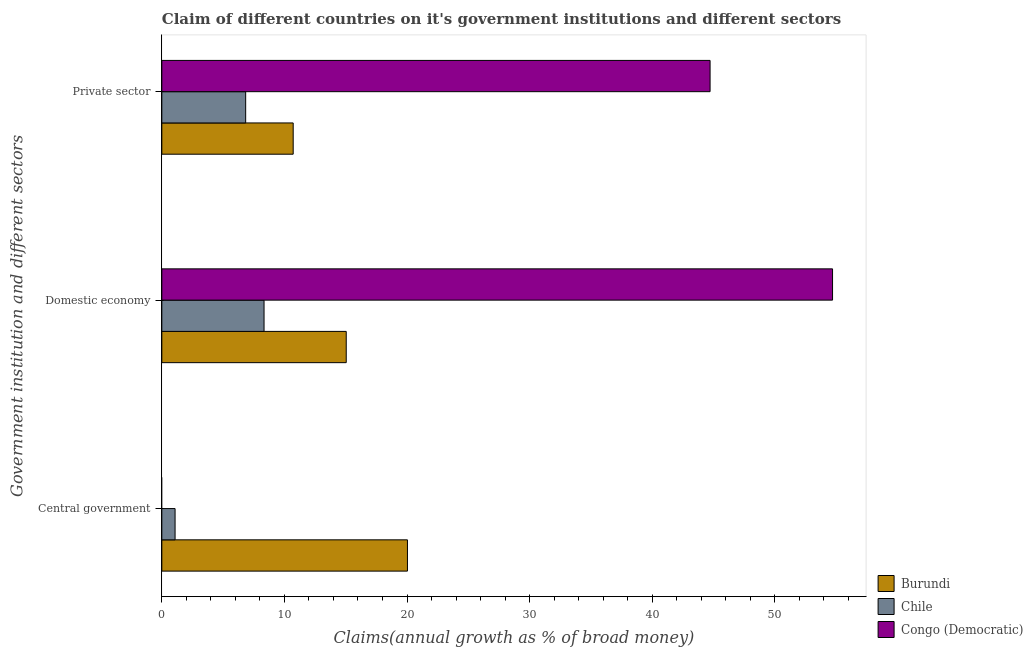How many different coloured bars are there?
Offer a very short reply. 3. How many groups of bars are there?
Provide a succinct answer. 3. Are the number of bars per tick equal to the number of legend labels?
Give a very brief answer. No. How many bars are there on the 1st tick from the top?
Your response must be concise. 3. How many bars are there on the 2nd tick from the bottom?
Make the answer very short. 3. What is the label of the 1st group of bars from the top?
Offer a very short reply. Private sector. What is the percentage of claim on the private sector in Congo (Democratic)?
Give a very brief answer. 44.72. Across all countries, what is the maximum percentage of claim on the domestic economy?
Offer a terse response. 54.71. Across all countries, what is the minimum percentage of claim on the private sector?
Your answer should be very brief. 6.84. In which country was the percentage of claim on the central government maximum?
Provide a short and direct response. Burundi. What is the total percentage of claim on the private sector in the graph?
Give a very brief answer. 62.28. What is the difference between the percentage of claim on the domestic economy in Chile and that in Burundi?
Provide a succinct answer. -6.7. What is the difference between the percentage of claim on the private sector in Congo (Democratic) and the percentage of claim on the domestic economy in Burundi?
Offer a very short reply. 29.68. What is the average percentage of claim on the domestic economy per country?
Ensure brevity in your answer.  26.03. What is the difference between the percentage of claim on the private sector and percentage of claim on the domestic economy in Chile?
Provide a succinct answer. -1.5. What is the ratio of the percentage of claim on the private sector in Chile to that in Burundi?
Offer a very short reply. 0.64. Is the percentage of claim on the central government in Chile less than that in Burundi?
Offer a terse response. Yes. What is the difference between the highest and the second highest percentage of claim on the domestic economy?
Your answer should be compact. 39.67. What is the difference between the highest and the lowest percentage of claim on the central government?
Your response must be concise. 20.04. In how many countries, is the percentage of claim on the domestic economy greater than the average percentage of claim on the domestic economy taken over all countries?
Offer a very short reply. 1. Is the sum of the percentage of claim on the private sector in Chile and Congo (Democratic) greater than the maximum percentage of claim on the central government across all countries?
Offer a very short reply. Yes. How many bars are there?
Provide a succinct answer. 8. Are all the bars in the graph horizontal?
Offer a very short reply. Yes. How many countries are there in the graph?
Offer a terse response. 3. Are the values on the major ticks of X-axis written in scientific E-notation?
Offer a terse response. No. How are the legend labels stacked?
Offer a very short reply. Vertical. What is the title of the graph?
Give a very brief answer. Claim of different countries on it's government institutions and different sectors. Does "Caribbean small states" appear as one of the legend labels in the graph?
Ensure brevity in your answer.  No. What is the label or title of the X-axis?
Keep it short and to the point. Claims(annual growth as % of broad money). What is the label or title of the Y-axis?
Ensure brevity in your answer.  Government institution and different sectors. What is the Claims(annual growth as % of broad money) in Burundi in Central government?
Provide a short and direct response. 20.04. What is the Claims(annual growth as % of broad money) of Chile in Central government?
Your response must be concise. 1.08. What is the Claims(annual growth as % of broad money) of Congo (Democratic) in Central government?
Provide a short and direct response. 0. What is the Claims(annual growth as % of broad money) in Burundi in Domestic economy?
Provide a short and direct response. 15.04. What is the Claims(annual growth as % of broad money) in Chile in Domestic economy?
Your answer should be very brief. 8.34. What is the Claims(annual growth as % of broad money) in Congo (Democratic) in Domestic economy?
Provide a short and direct response. 54.71. What is the Claims(annual growth as % of broad money) of Burundi in Private sector?
Your answer should be very brief. 10.72. What is the Claims(annual growth as % of broad money) in Chile in Private sector?
Provide a short and direct response. 6.84. What is the Claims(annual growth as % of broad money) in Congo (Democratic) in Private sector?
Your answer should be very brief. 44.72. Across all Government institution and different sectors, what is the maximum Claims(annual growth as % of broad money) of Burundi?
Offer a terse response. 20.04. Across all Government institution and different sectors, what is the maximum Claims(annual growth as % of broad money) of Chile?
Keep it short and to the point. 8.34. Across all Government institution and different sectors, what is the maximum Claims(annual growth as % of broad money) in Congo (Democratic)?
Give a very brief answer. 54.71. Across all Government institution and different sectors, what is the minimum Claims(annual growth as % of broad money) in Burundi?
Ensure brevity in your answer.  10.72. Across all Government institution and different sectors, what is the minimum Claims(annual growth as % of broad money) of Chile?
Keep it short and to the point. 1.08. Across all Government institution and different sectors, what is the minimum Claims(annual growth as % of broad money) of Congo (Democratic)?
Offer a very short reply. 0. What is the total Claims(annual growth as % of broad money) of Burundi in the graph?
Offer a very short reply. 45.79. What is the total Claims(annual growth as % of broad money) of Chile in the graph?
Your answer should be compact. 16.26. What is the total Claims(annual growth as % of broad money) of Congo (Democratic) in the graph?
Ensure brevity in your answer.  99.43. What is the difference between the Claims(annual growth as % of broad money) of Burundi in Central government and that in Domestic economy?
Your answer should be compact. 4.99. What is the difference between the Claims(annual growth as % of broad money) of Chile in Central government and that in Domestic economy?
Ensure brevity in your answer.  -7.26. What is the difference between the Claims(annual growth as % of broad money) in Burundi in Central government and that in Private sector?
Your answer should be very brief. 9.32. What is the difference between the Claims(annual growth as % of broad money) in Chile in Central government and that in Private sector?
Make the answer very short. -5.76. What is the difference between the Claims(annual growth as % of broad money) of Burundi in Domestic economy and that in Private sector?
Provide a short and direct response. 4.33. What is the difference between the Claims(annual growth as % of broad money) of Chile in Domestic economy and that in Private sector?
Provide a succinct answer. 1.5. What is the difference between the Claims(annual growth as % of broad money) of Congo (Democratic) in Domestic economy and that in Private sector?
Offer a terse response. 9.99. What is the difference between the Claims(annual growth as % of broad money) in Burundi in Central government and the Claims(annual growth as % of broad money) in Chile in Domestic economy?
Your answer should be compact. 11.7. What is the difference between the Claims(annual growth as % of broad money) of Burundi in Central government and the Claims(annual growth as % of broad money) of Congo (Democratic) in Domestic economy?
Keep it short and to the point. -34.68. What is the difference between the Claims(annual growth as % of broad money) of Chile in Central government and the Claims(annual growth as % of broad money) of Congo (Democratic) in Domestic economy?
Offer a very short reply. -53.63. What is the difference between the Claims(annual growth as % of broad money) of Burundi in Central government and the Claims(annual growth as % of broad money) of Chile in Private sector?
Your answer should be very brief. 13.2. What is the difference between the Claims(annual growth as % of broad money) of Burundi in Central government and the Claims(annual growth as % of broad money) of Congo (Democratic) in Private sector?
Make the answer very short. -24.69. What is the difference between the Claims(annual growth as % of broad money) of Chile in Central government and the Claims(annual growth as % of broad money) of Congo (Democratic) in Private sector?
Ensure brevity in your answer.  -43.64. What is the difference between the Claims(annual growth as % of broad money) of Burundi in Domestic economy and the Claims(annual growth as % of broad money) of Chile in Private sector?
Your answer should be compact. 8.2. What is the difference between the Claims(annual growth as % of broad money) of Burundi in Domestic economy and the Claims(annual growth as % of broad money) of Congo (Democratic) in Private sector?
Make the answer very short. -29.68. What is the difference between the Claims(annual growth as % of broad money) of Chile in Domestic economy and the Claims(annual growth as % of broad money) of Congo (Democratic) in Private sector?
Your answer should be very brief. -36.38. What is the average Claims(annual growth as % of broad money) of Burundi per Government institution and different sectors?
Ensure brevity in your answer.  15.26. What is the average Claims(annual growth as % of broad money) in Chile per Government institution and different sectors?
Provide a short and direct response. 5.42. What is the average Claims(annual growth as % of broad money) in Congo (Democratic) per Government institution and different sectors?
Offer a terse response. 33.14. What is the difference between the Claims(annual growth as % of broad money) of Burundi and Claims(annual growth as % of broad money) of Chile in Central government?
Ensure brevity in your answer.  18.96. What is the difference between the Claims(annual growth as % of broad money) of Burundi and Claims(annual growth as % of broad money) of Chile in Domestic economy?
Keep it short and to the point. 6.7. What is the difference between the Claims(annual growth as % of broad money) of Burundi and Claims(annual growth as % of broad money) of Congo (Democratic) in Domestic economy?
Keep it short and to the point. -39.67. What is the difference between the Claims(annual growth as % of broad money) of Chile and Claims(annual growth as % of broad money) of Congo (Democratic) in Domestic economy?
Provide a succinct answer. -46.37. What is the difference between the Claims(annual growth as % of broad money) in Burundi and Claims(annual growth as % of broad money) in Chile in Private sector?
Keep it short and to the point. 3.88. What is the difference between the Claims(annual growth as % of broad money) of Burundi and Claims(annual growth as % of broad money) of Congo (Democratic) in Private sector?
Provide a short and direct response. -34.01. What is the difference between the Claims(annual growth as % of broad money) in Chile and Claims(annual growth as % of broad money) in Congo (Democratic) in Private sector?
Provide a short and direct response. -37.88. What is the ratio of the Claims(annual growth as % of broad money) in Burundi in Central government to that in Domestic economy?
Provide a short and direct response. 1.33. What is the ratio of the Claims(annual growth as % of broad money) of Chile in Central government to that in Domestic economy?
Provide a succinct answer. 0.13. What is the ratio of the Claims(annual growth as % of broad money) in Burundi in Central government to that in Private sector?
Make the answer very short. 1.87. What is the ratio of the Claims(annual growth as % of broad money) in Chile in Central government to that in Private sector?
Offer a very short reply. 0.16. What is the ratio of the Claims(annual growth as % of broad money) of Burundi in Domestic economy to that in Private sector?
Provide a short and direct response. 1.4. What is the ratio of the Claims(annual growth as % of broad money) of Chile in Domestic economy to that in Private sector?
Provide a succinct answer. 1.22. What is the ratio of the Claims(annual growth as % of broad money) of Congo (Democratic) in Domestic economy to that in Private sector?
Your response must be concise. 1.22. What is the difference between the highest and the second highest Claims(annual growth as % of broad money) in Burundi?
Provide a succinct answer. 4.99. What is the difference between the highest and the second highest Claims(annual growth as % of broad money) in Chile?
Make the answer very short. 1.5. What is the difference between the highest and the lowest Claims(annual growth as % of broad money) of Burundi?
Offer a terse response. 9.32. What is the difference between the highest and the lowest Claims(annual growth as % of broad money) in Chile?
Make the answer very short. 7.26. What is the difference between the highest and the lowest Claims(annual growth as % of broad money) of Congo (Democratic)?
Keep it short and to the point. 54.71. 